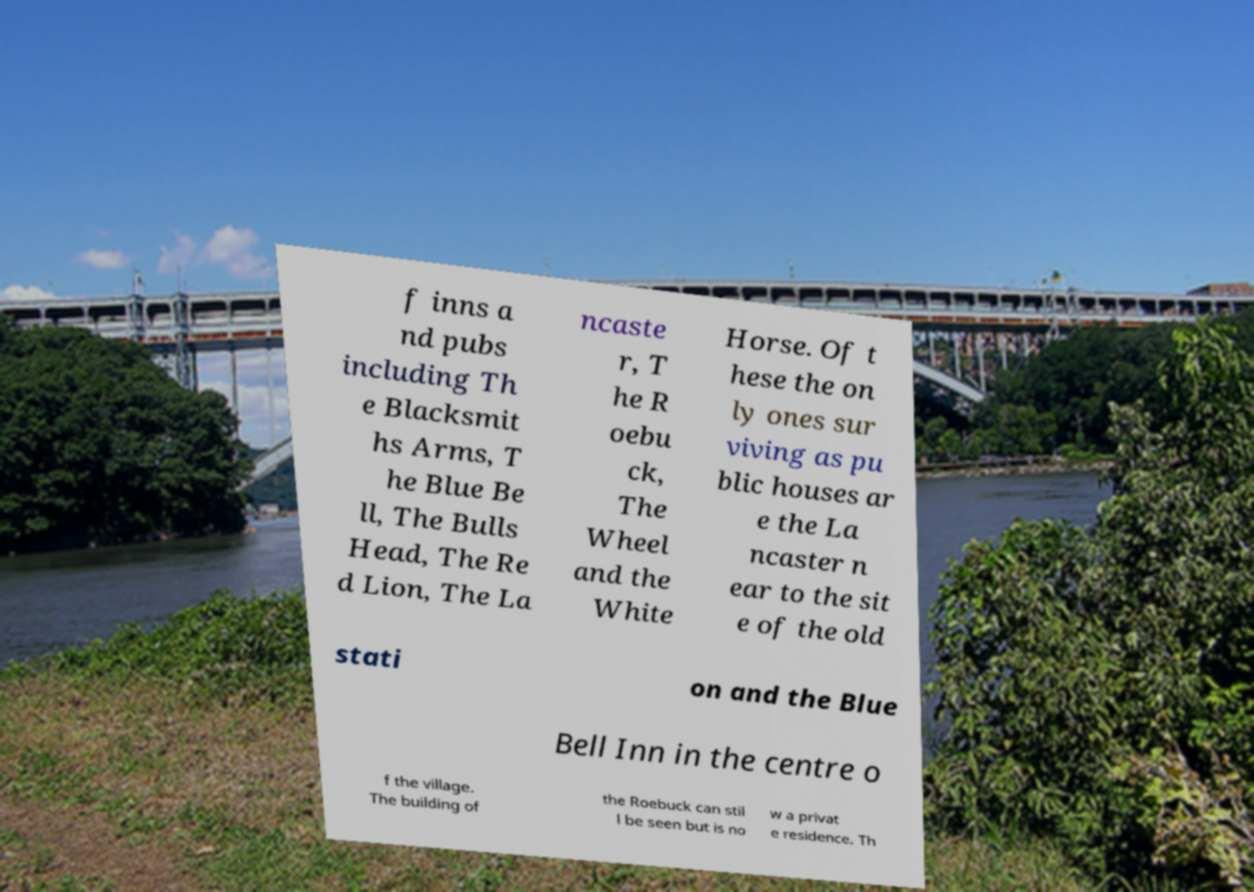Can you accurately transcribe the text from the provided image for me? f inns a nd pubs including Th e Blacksmit hs Arms, T he Blue Be ll, The Bulls Head, The Re d Lion, The La ncaste r, T he R oebu ck, The Wheel and the White Horse. Of t hese the on ly ones sur viving as pu blic houses ar e the La ncaster n ear to the sit e of the old stati on and the Blue Bell Inn in the centre o f the village. The building of the Roebuck can stil l be seen but is no w a privat e residence. Th 